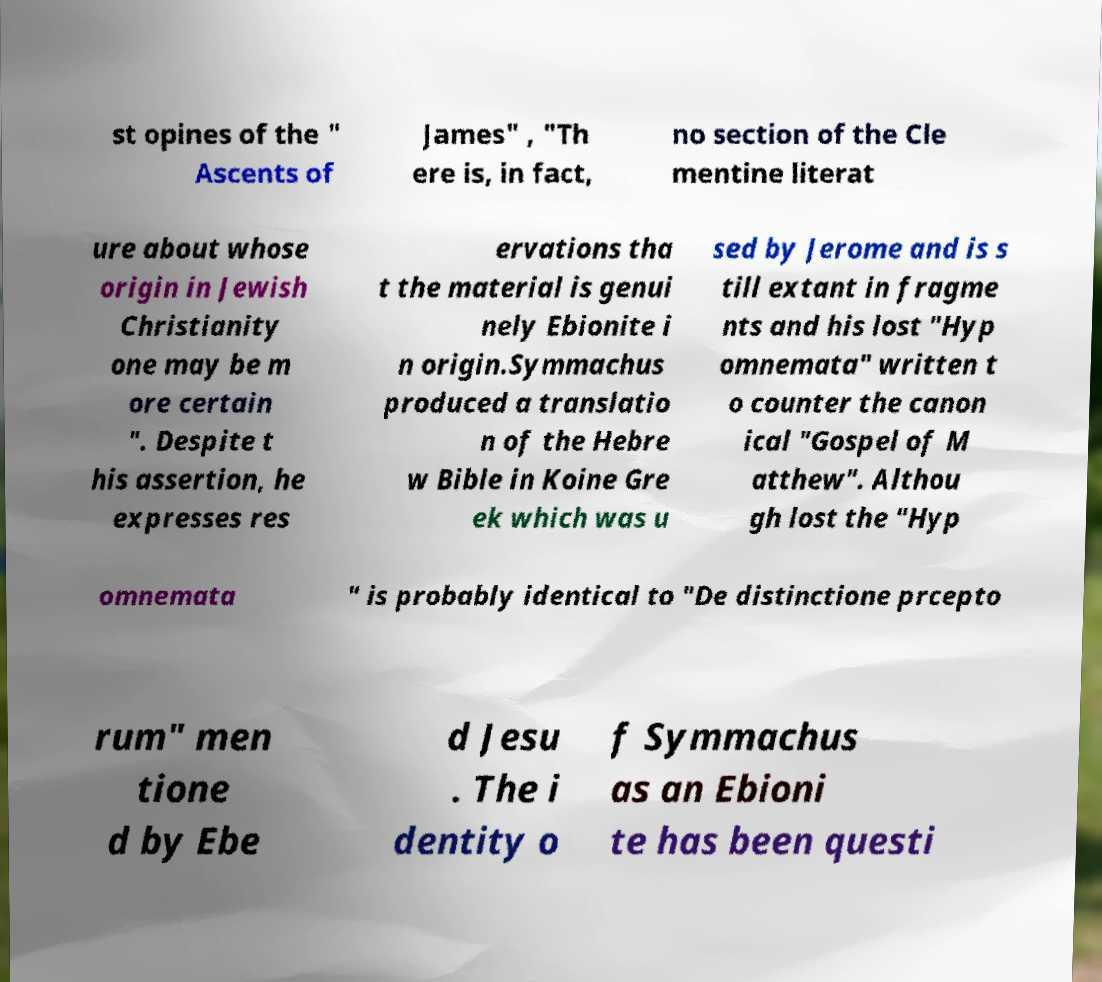I need the written content from this picture converted into text. Can you do that? st opines of the " Ascents of James" , "Th ere is, in fact, no section of the Cle mentine literat ure about whose origin in Jewish Christianity one may be m ore certain ". Despite t his assertion, he expresses res ervations tha t the material is genui nely Ebionite i n origin.Symmachus produced a translatio n of the Hebre w Bible in Koine Gre ek which was u sed by Jerome and is s till extant in fragme nts and his lost "Hyp omnemata" written t o counter the canon ical "Gospel of M atthew". Althou gh lost the "Hyp omnemata " is probably identical to "De distinctione prcepto rum" men tione d by Ebe d Jesu . The i dentity o f Symmachus as an Ebioni te has been questi 